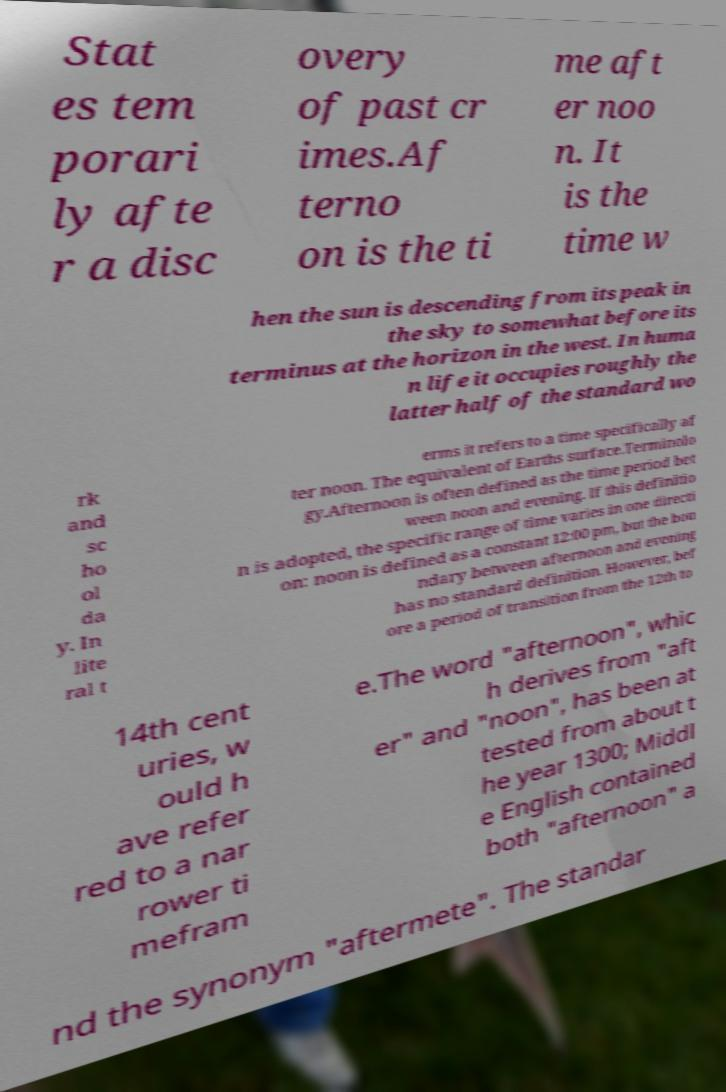Can you accurately transcribe the text from the provided image for me? Stat es tem porari ly afte r a disc overy of past cr imes.Af terno on is the ti me aft er noo n. It is the time w hen the sun is descending from its peak in the sky to somewhat before its terminus at the horizon in the west. In huma n life it occupies roughly the latter half of the standard wo rk and sc ho ol da y. In lite ral t erms it refers to a time specifically af ter noon. The equivalent of Earths surface.Terminolo gy.Afternoon is often defined as the time period bet ween noon and evening. If this definitio n is adopted, the specific range of time varies in one directi on: noon is defined as a constant 12:00 pm, but the bou ndary between afternoon and evening has no standard definition. However, bef ore a period of transition from the 12th to 14th cent uries, w ould h ave refer red to a nar rower ti mefram e.The word "afternoon", whic h derives from "aft er" and "noon", has been at tested from about t he year 1300; Middl e English contained both "afternoon" a nd the synonym "aftermete". The standar 